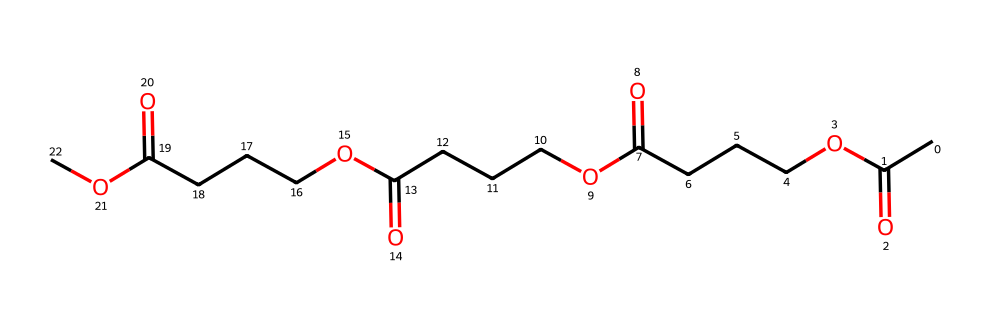What is the molecular formula of this compound? To determine the molecular formula, analyze the SMILES representation which indicates the presence of four repeating units, each with an acetyl group (CC(=O)O) followed by a carbon chain (CCCC) and carboxylic acid groups. Combining the elements leads to the empirical molecular formula of C16H30O5.
Answer: C16H30O5 How many carboxylic acid groups are present in this structure? In the SMILES representation, each occurrence of C(=O)O indicates a carboxylic acid group. The structure shows a total of four distinct sections, each ending in a carboxylic acid group, confirming the presence of four such groups.
Answer: 4 What type of polymer is represented by this structure? The structure indicates a polyacid due to the presence of multiple carboxylic acid groups attached to a backbone formed by carbon chains. Thus, it indicates that this compound is a type of polyester.
Answer: polyester How many total carbon atoms are there in this polymer? Count the carbon atoms indicated in the SMILES. The backbone consists of 12 carbon atoms from the chain (four FFF segments with three C’s each) and 4 from the acetyl groups, totaling up to 16 carbon atoms.
Answer: 16 What property of this polymer contributes to its use in official uniforms? The presence of long hydrocarbon chains and carboxylic acid groups contributes to properties such as durability and resistance to wear. The alternating structure allows for flexibility and strength, making it suitable for uniforms.
Answer: durability 